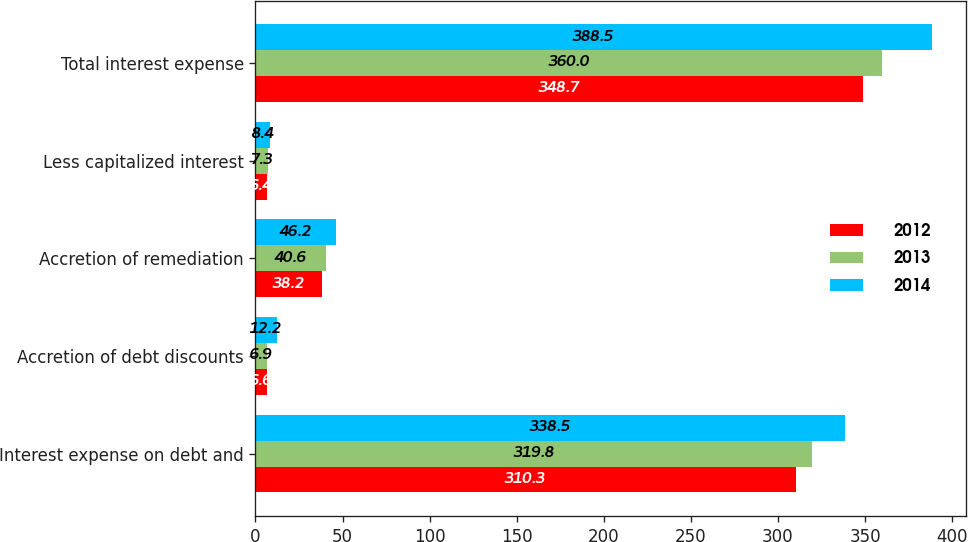Convert chart to OTSL. <chart><loc_0><loc_0><loc_500><loc_500><stacked_bar_chart><ecel><fcel>Interest expense on debt and<fcel>Accretion of debt discounts<fcel>Accretion of remediation<fcel>Less capitalized interest<fcel>Total interest expense<nl><fcel>2012<fcel>310.3<fcel>6.6<fcel>38.2<fcel>6.4<fcel>348.7<nl><fcel>2013<fcel>319.8<fcel>6.9<fcel>40.6<fcel>7.3<fcel>360<nl><fcel>2014<fcel>338.5<fcel>12.2<fcel>46.2<fcel>8.4<fcel>388.5<nl></chart> 